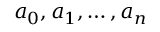Convert formula to latex. <formula><loc_0><loc_0><loc_500><loc_500>a _ { 0 } , a _ { 1 } , \dots , a _ { n }</formula> 